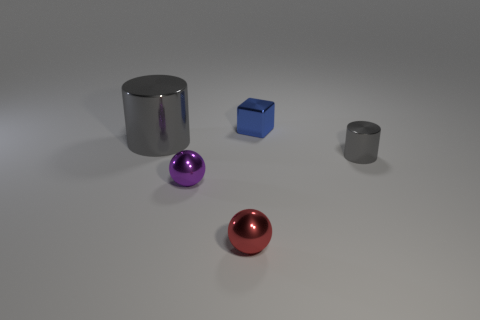Add 4 tiny brown cylinders. How many objects exist? 9 Subtract all cylinders. How many objects are left? 3 Add 1 large purple blocks. How many large purple blocks exist? 1 Subtract 0 gray balls. How many objects are left? 5 Subtract all red cylinders. Subtract all metal balls. How many objects are left? 3 Add 5 small spheres. How many small spheres are left? 7 